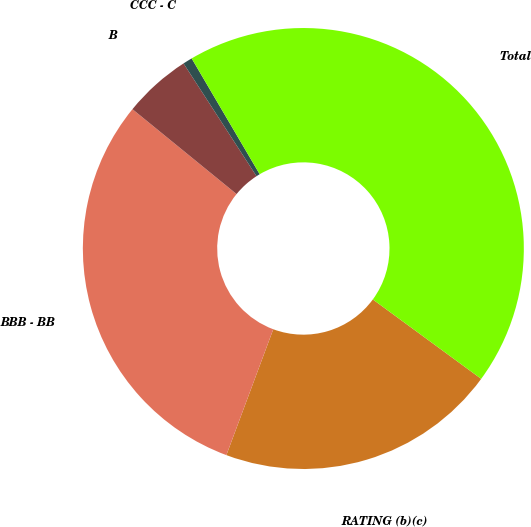Convert chart. <chart><loc_0><loc_0><loc_500><loc_500><pie_chart><fcel>RATING (b)(c)<fcel>BBB - BB<fcel>B<fcel>CCC - C<fcel>Total<nl><fcel>20.61%<fcel>30.21%<fcel>4.97%<fcel>0.69%<fcel>43.52%<nl></chart> 